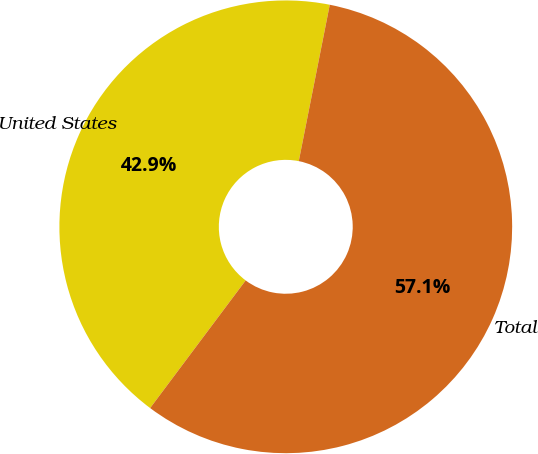Convert chart. <chart><loc_0><loc_0><loc_500><loc_500><pie_chart><fcel>United States<fcel>Total<nl><fcel>42.89%<fcel>57.11%<nl></chart> 